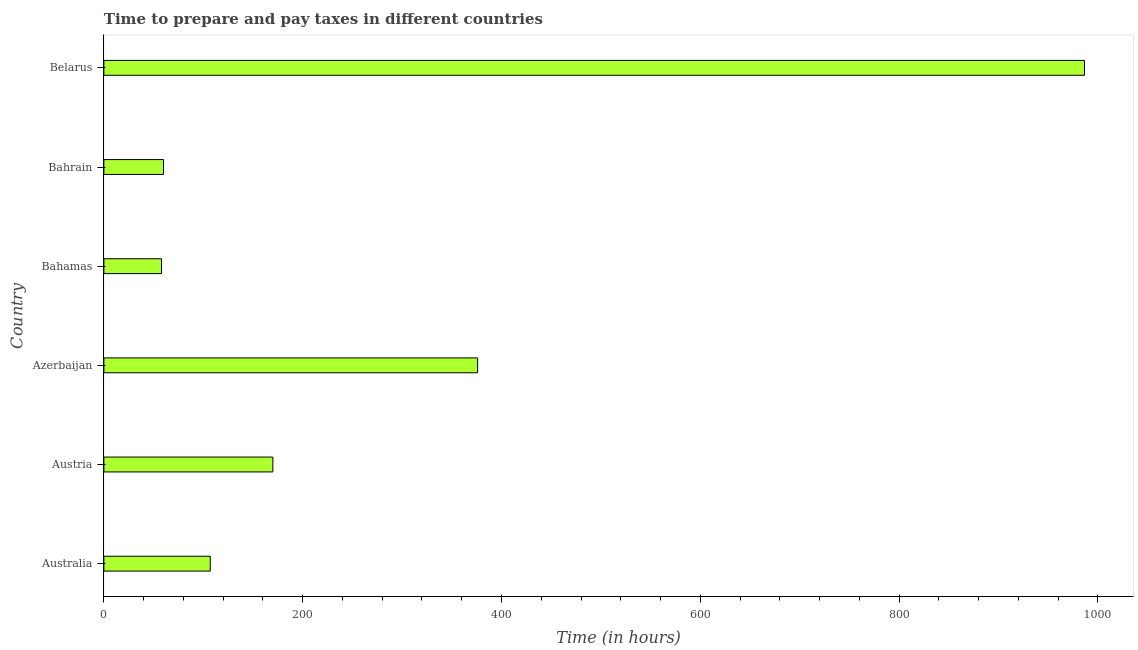What is the title of the graph?
Make the answer very short. Time to prepare and pay taxes in different countries. What is the label or title of the X-axis?
Give a very brief answer. Time (in hours). What is the label or title of the Y-axis?
Your answer should be very brief. Country. What is the time to prepare and pay taxes in Australia?
Provide a short and direct response. 107. Across all countries, what is the maximum time to prepare and pay taxes?
Your answer should be very brief. 986.5. In which country was the time to prepare and pay taxes maximum?
Your answer should be compact. Belarus. In which country was the time to prepare and pay taxes minimum?
Make the answer very short. Bahamas. What is the sum of the time to prepare and pay taxes?
Your answer should be compact. 1757.5. What is the average time to prepare and pay taxes per country?
Ensure brevity in your answer.  292.92. What is the median time to prepare and pay taxes?
Make the answer very short. 138.5. In how many countries, is the time to prepare and pay taxes greater than 720 hours?
Keep it short and to the point. 1. What is the ratio of the time to prepare and pay taxes in Austria to that in Azerbaijan?
Offer a terse response. 0.45. Is the time to prepare and pay taxes in Azerbaijan less than that in Belarus?
Give a very brief answer. Yes. Is the difference between the time to prepare and pay taxes in Austria and Azerbaijan greater than the difference between any two countries?
Make the answer very short. No. What is the difference between the highest and the second highest time to prepare and pay taxes?
Offer a very short reply. 610.5. Is the sum of the time to prepare and pay taxes in Bahamas and Belarus greater than the maximum time to prepare and pay taxes across all countries?
Your answer should be very brief. Yes. What is the difference between the highest and the lowest time to prepare and pay taxes?
Offer a terse response. 928.5. In how many countries, is the time to prepare and pay taxes greater than the average time to prepare and pay taxes taken over all countries?
Provide a short and direct response. 2. Are all the bars in the graph horizontal?
Provide a succinct answer. Yes. What is the difference between two consecutive major ticks on the X-axis?
Provide a succinct answer. 200. What is the Time (in hours) of Australia?
Your response must be concise. 107. What is the Time (in hours) in Austria?
Offer a terse response. 170. What is the Time (in hours) in Azerbaijan?
Provide a short and direct response. 376. What is the Time (in hours) of Belarus?
Provide a short and direct response. 986.5. What is the difference between the Time (in hours) in Australia and Austria?
Offer a very short reply. -63. What is the difference between the Time (in hours) in Australia and Azerbaijan?
Provide a succinct answer. -269. What is the difference between the Time (in hours) in Australia and Bahamas?
Your answer should be compact. 49. What is the difference between the Time (in hours) in Australia and Belarus?
Provide a short and direct response. -879.5. What is the difference between the Time (in hours) in Austria and Azerbaijan?
Your answer should be compact. -206. What is the difference between the Time (in hours) in Austria and Bahamas?
Your answer should be compact. 112. What is the difference between the Time (in hours) in Austria and Bahrain?
Your answer should be very brief. 110. What is the difference between the Time (in hours) in Austria and Belarus?
Offer a terse response. -816.5. What is the difference between the Time (in hours) in Azerbaijan and Bahamas?
Ensure brevity in your answer.  318. What is the difference between the Time (in hours) in Azerbaijan and Bahrain?
Give a very brief answer. 316. What is the difference between the Time (in hours) in Azerbaijan and Belarus?
Your response must be concise. -610.5. What is the difference between the Time (in hours) in Bahamas and Belarus?
Ensure brevity in your answer.  -928.5. What is the difference between the Time (in hours) in Bahrain and Belarus?
Ensure brevity in your answer.  -926.5. What is the ratio of the Time (in hours) in Australia to that in Austria?
Offer a terse response. 0.63. What is the ratio of the Time (in hours) in Australia to that in Azerbaijan?
Your answer should be very brief. 0.28. What is the ratio of the Time (in hours) in Australia to that in Bahamas?
Offer a very short reply. 1.84. What is the ratio of the Time (in hours) in Australia to that in Bahrain?
Your response must be concise. 1.78. What is the ratio of the Time (in hours) in Australia to that in Belarus?
Make the answer very short. 0.11. What is the ratio of the Time (in hours) in Austria to that in Azerbaijan?
Offer a very short reply. 0.45. What is the ratio of the Time (in hours) in Austria to that in Bahamas?
Give a very brief answer. 2.93. What is the ratio of the Time (in hours) in Austria to that in Bahrain?
Offer a very short reply. 2.83. What is the ratio of the Time (in hours) in Austria to that in Belarus?
Your answer should be very brief. 0.17. What is the ratio of the Time (in hours) in Azerbaijan to that in Bahamas?
Your response must be concise. 6.48. What is the ratio of the Time (in hours) in Azerbaijan to that in Bahrain?
Give a very brief answer. 6.27. What is the ratio of the Time (in hours) in Azerbaijan to that in Belarus?
Provide a succinct answer. 0.38. What is the ratio of the Time (in hours) in Bahamas to that in Belarus?
Your answer should be compact. 0.06. What is the ratio of the Time (in hours) in Bahrain to that in Belarus?
Ensure brevity in your answer.  0.06. 